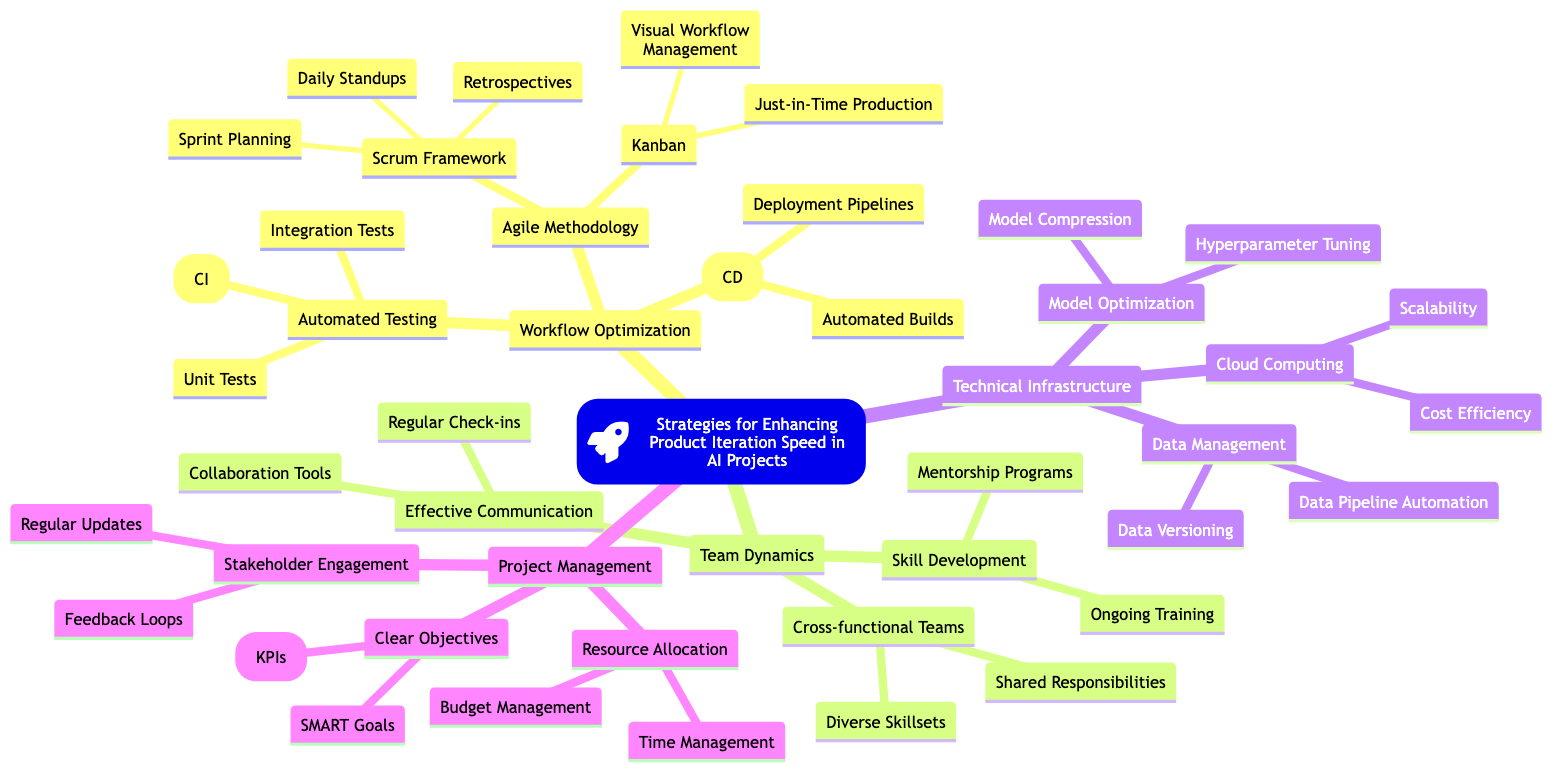What is the root node of the diagram? The root node is titled "Strategies for Enhancing Product Iteration Speed in AI Projects," which serves as the main focus of the concept map.
Answer: Strategies for Enhancing Product Iteration Speed in AI Projects How many main categories are connected to the root node? There are four main categories connected to the root node: Workflow Optimization, Team Dynamics, Technical Infrastructure, and Project Management. This is counted directly from the top-level nodes branching from the root.
Answer: 4 What is one component of Agile Methodology? One of the components of Agile Methodology is the Scrum Framework, which is a subcategory detailing a specific approach within Agile practices. This is identified under the Agile Methodology node.
Answer: Scrum Framework Which testing type is included under Automated Testing? Unit Tests are one of the types of testing included under Automated Testing. This can be found by checking the children nodes under Automated Testing.
Answer: Unit Tests What is a benefit of Cloud Computing listed in the diagram? Scalability is listed as a benefit of Cloud Computing in the Technical Infrastructure section, which emphasizes the ability to grow resources as needed.
Answer: Scalability Which project management strategy involves defining measurable outcomes? SMART Goals are included in the Project Management section as a strategy for creating clear and measurable objectives, which outlines specific criteria for success.
Answer: SMART Goals What do Cross-functional Teams promote in team dynamics? Cross-functional Teams promote Shared Responsibilities among team members, which is highlighted in the Team Dynamics section under Cross-functional Teams.
Answer: Shared Responsibilities How many components are there under Continuous Deployment? There are two components under Continuous Deployment: Automated Builds and Deployment Pipelines. This can be counted directly from the nodes associated with Continuous Deployment.
Answer: 2 What type of engagement is suggested for stakeholders? Regular Updates are suggested as a form of Stakeholder Engagement to keep parties informed and involved in the project, as detailed in the Project Management section.
Answer: Regular Updates Which form of skill development involves guidance from experienced individuals? Mentorship Programs are a form of skill development that involves guidance from experienced individuals, as noted under the Skill Development category in Team Dynamics.
Answer: Mentorship Programs 